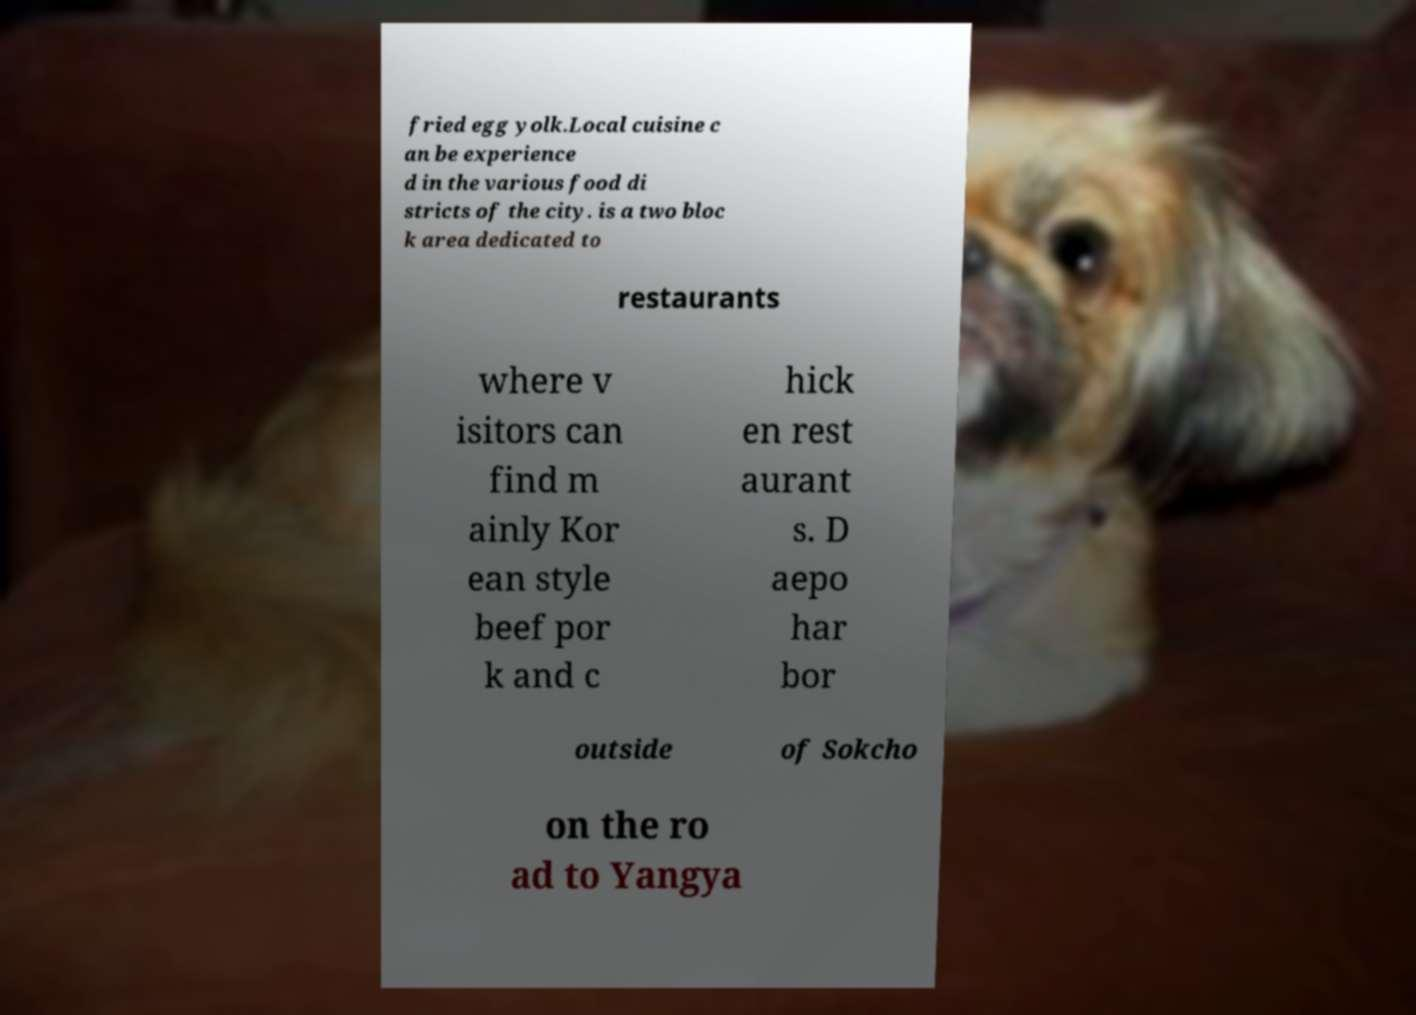Please read and relay the text visible in this image. What does it say? fried egg yolk.Local cuisine c an be experience d in the various food di stricts of the city. is a two bloc k area dedicated to restaurants where v isitors can find m ainly Kor ean style beef por k and c hick en rest aurant s. D aepo har bor outside of Sokcho on the ro ad to Yangya 